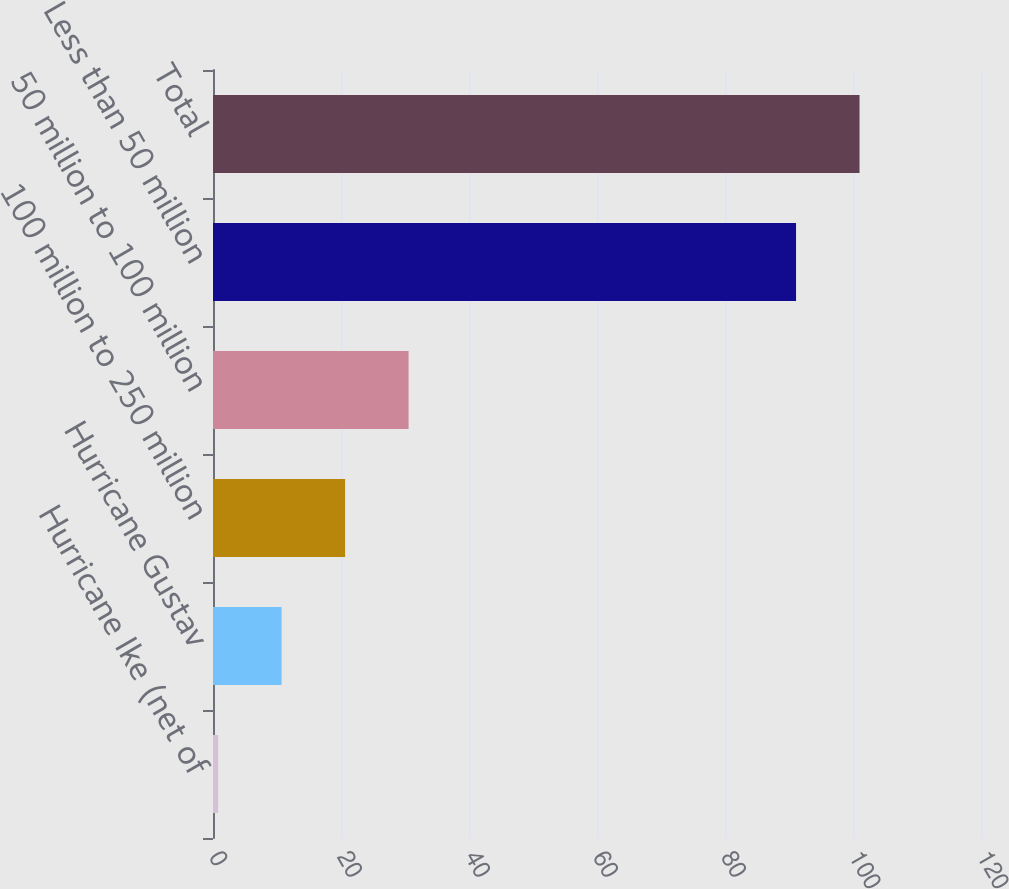Convert chart to OTSL. <chart><loc_0><loc_0><loc_500><loc_500><bar_chart><fcel>Hurricane Ike (net of<fcel>Hurricane Gustav<fcel>100 million to 250 million<fcel>50 million to 100 million<fcel>Less than 50 million<fcel>Total<nl><fcel>0.8<fcel>10.72<fcel>20.64<fcel>30.56<fcel>91.1<fcel>101.02<nl></chart> 